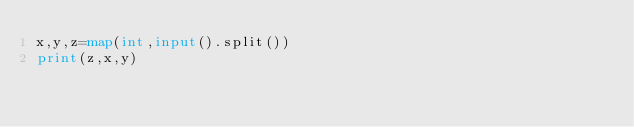<code> <loc_0><loc_0><loc_500><loc_500><_Python_>x,y,z=map(int,input().split())
print(z,x,y)</code> 